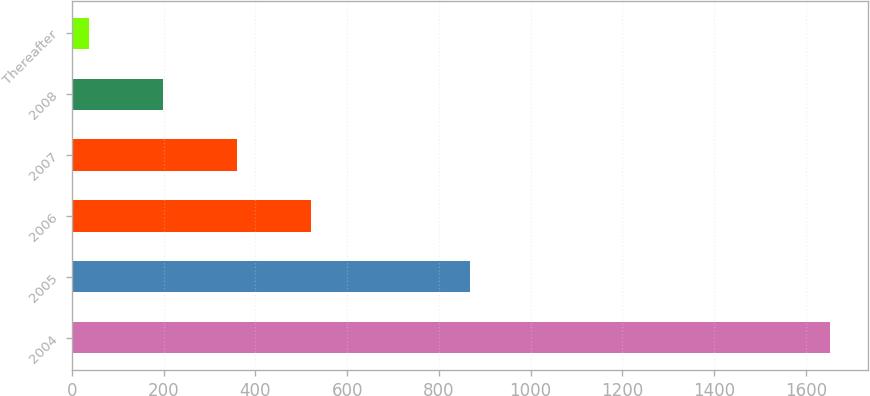Convert chart. <chart><loc_0><loc_0><loc_500><loc_500><bar_chart><fcel>2004<fcel>2005<fcel>2006<fcel>2007<fcel>2008<fcel>Thereafter<nl><fcel>1653<fcel>867<fcel>521.8<fcel>360.2<fcel>198.6<fcel>37<nl></chart> 